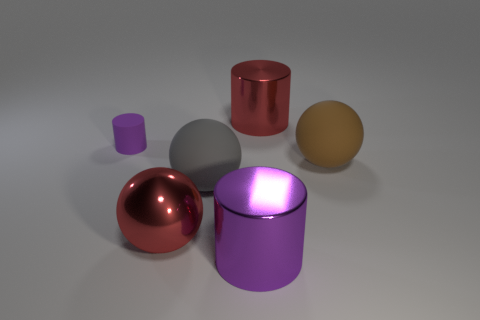Subtract all metallic cylinders. How many cylinders are left? 1 Subtract all purple cylinders. How many cylinders are left? 1 Add 3 big matte things. How many objects exist? 9 Subtract 1 spheres. How many spheres are left? 2 Subtract all big brown cylinders. Subtract all metallic balls. How many objects are left? 5 Add 2 purple cylinders. How many purple cylinders are left? 4 Add 5 yellow metallic cylinders. How many yellow metallic cylinders exist? 5 Subtract 1 gray balls. How many objects are left? 5 Subtract all gray cylinders. Subtract all cyan cubes. How many cylinders are left? 3 Subtract all red blocks. How many red cylinders are left? 1 